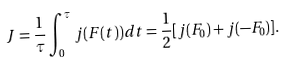<formula> <loc_0><loc_0><loc_500><loc_500>J = \frac { 1 } { \tau } \int ^ { \tau } _ { 0 } j ( F ( t ) ) d t = \frac { 1 } { 2 } [ j ( F _ { 0 } ) + j ( - F _ { 0 } ) ] .</formula> 